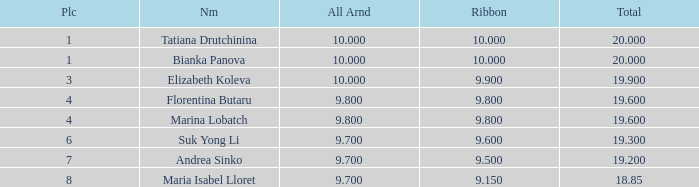What place had a ribbon below 9.8 and a 19.2 total? 7.0. 